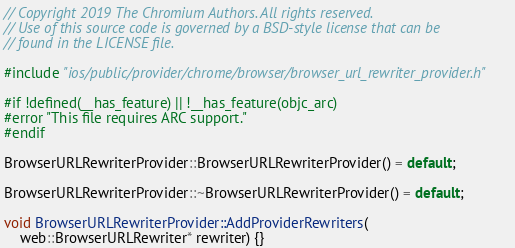Convert code to text. <code><loc_0><loc_0><loc_500><loc_500><_ObjectiveC_>// Copyright 2019 The Chromium Authors. All rights reserved.
// Use of this source code is governed by a BSD-style license that can be
// found in the LICENSE file.

#include "ios/public/provider/chrome/browser/browser_url_rewriter_provider.h"

#if !defined(__has_feature) || !__has_feature(objc_arc)
#error "This file requires ARC support."
#endif

BrowserURLRewriterProvider::BrowserURLRewriterProvider() = default;

BrowserURLRewriterProvider::~BrowserURLRewriterProvider() = default;

void BrowserURLRewriterProvider::AddProviderRewriters(
    web::BrowserURLRewriter* rewriter) {}
</code> 